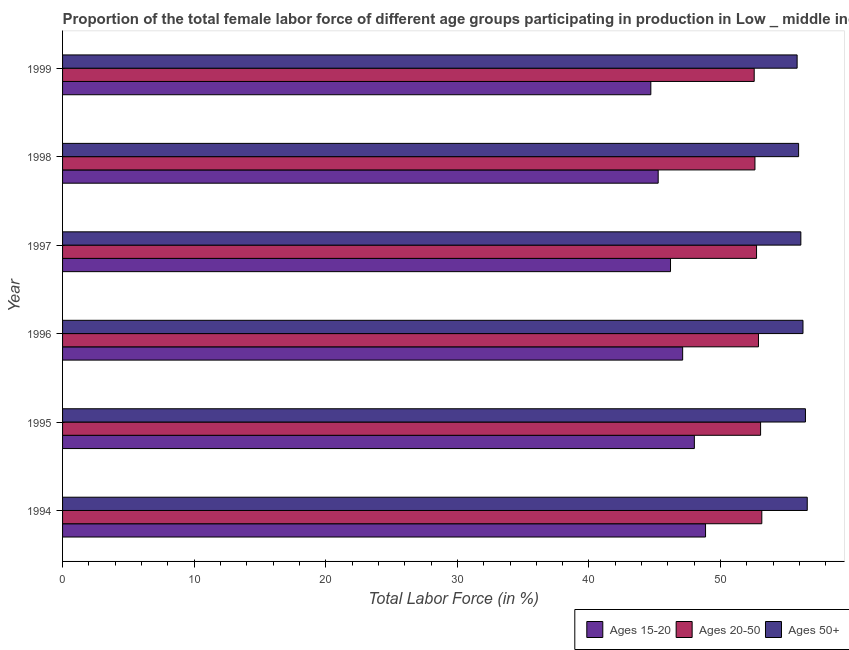How many different coloured bars are there?
Your answer should be compact. 3. Are the number of bars per tick equal to the number of legend labels?
Provide a short and direct response. Yes. Are the number of bars on each tick of the Y-axis equal?
Provide a short and direct response. Yes. How many bars are there on the 6th tick from the top?
Your response must be concise. 3. How many bars are there on the 2nd tick from the bottom?
Provide a succinct answer. 3. In how many cases, is the number of bars for a given year not equal to the number of legend labels?
Your response must be concise. 0. What is the percentage of female labor force within the age group 20-50 in 1999?
Give a very brief answer. 52.55. Across all years, what is the maximum percentage of female labor force within the age group 20-50?
Provide a succinct answer. 53.13. Across all years, what is the minimum percentage of female labor force within the age group 15-20?
Your answer should be compact. 44.7. In which year was the percentage of female labor force above age 50 minimum?
Offer a terse response. 1999. What is the total percentage of female labor force within the age group 20-50 in the graph?
Your answer should be compact. 316.95. What is the difference between the percentage of female labor force above age 50 in 1995 and that in 1996?
Keep it short and to the point. 0.19. What is the difference between the percentage of female labor force above age 50 in 1998 and the percentage of female labor force within the age group 20-50 in 1999?
Keep it short and to the point. 3.37. What is the average percentage of female labor force within the age group 15-20 per year?
Offer a very short reply. 46.69. In the year 1996, what is the difference between the percentage of female labor force above age 50 and percentage of female labor force within the age group 20-50?
Your answer should be very brief. 3.38. Is the percentage of female labor force within the age group 20-50 in 1994 less than that in 1998?
Ensure brevity in your answer.  No. What is the difference between the highest and the second highest percentage of female labor force within the age group 20-50?
Give a very brief answer. 0.09. What is the difference between the highest and the lowest percentage of female labor force within the age group 20-50?
Your response must be concise. 0.58. What does the 1st bar from the top in 1996 represents?
Your response must be concise. Ages 50+. What does the 3rd bar from the bottom in 1998 represents?
Your response must be concise. Ages 50+. How many bars are there?
Make the answer very short. 18. What is the difference between two consecutive major ticks on the X-axis?
Provide a short and direct response. 10. Are the values on the major ticks of X-axis written in scientific E-notation?
Your answer should be compact. No. Does the graph contain grids?
Your answer should be very brief. No. How many legend labels are there?
Your answer should be compact. 3. How are the legend labels stacked?
Make the answer very short. Horizontal. What is the title of the graph?
Give a very brief answer. Proportion of the total female labor force of different age groups participating in production in Low _ middle income. What is the label or title of the X-axis?
Provide a short and direct response. Total Labor Force (in %). What is the Total Labor Force (in %) in Ages 15-20 in 1994?
Make the answer very short. 48.86. What is the Total Labor Force (in %) in Ages 20-50 in 1994?
Provide a succinct answer. 53.13. What is the Total Labor Force (in %) of Ages 50+ in 1994?
Offer a very short reply. 56.59. What is the Total Labor Force (in %) in Ages 15-20 in 1995?
Give a very brief answer. 48.01. What is the Total Labor Force (in %) of Ages 20-50 in 1995?
Offer a very short reply. 53.04. What is the Total Labor Force (in %) in Ages 50+ in 1995?
Keep it short and to the point. 56.45. What is the Total Labor Force (in %) of Ages 15-20 in 1996?
Your response must be concise. 47.12. What is the Total Labor Force (in %) of Ages 20-50 in 1996?
Make the answer very short. 52.88. What is the Total Labor Force (in %) of Ages 50+ in 1996?
Ensure brevity in your answer.  56.26. What is the Total Labor Force (in %) of Ages 15-20 in 1997?
Offer a very short reply. 46.2. What is the Total Labor Force (in %) in Ages 20-50 in 1997?
Make the answer very short. 52.73. What is the Total Labor Force (in %) of Ages 50+ in 1997?
Provide a succinct answer. 56.1. What is the Total Labor Force (in %) in Ages 15-20 in 1998?
Your response must be concise. 45.26. What is the Total Labor Force (in %) in Ages 20-50 in 1998?
Make the answer very short. 52.61. What is the Total Labor Force (in %) of Ages 50+ in 1998?
Your response must be concise. 55.93. What is the Total Labor Force (in %) in Ages 15-20 in 1999?
Make the answer very short. 44.7. What is the Total Labor Force (in %) in Ages 20-50 in 1999?
Ensure brevity in your answer.  52.55. What is the Total Labor Force (in %) in Ages 50+ in 1999?
Keep it short and to the point. 55.82. Across all years, what is the maximum Total Labor Force (in %) of Ages 15-20?
Give a very brief answer. 48.86. Across all years, what is the maximum Total Labor Force (in %) of Ages 20-50?
Keep it short and to the point. 53.13. Across all years, what is the maximum Total Labor Force (in %) of Ages 50+?
Keep it short and to the point. 56.59. Across all years, what is the minimum Total Labor Force (in %) in Ages 15-20?
Offer a very short reply. 44.7. Across all years, what is the minimum Total Labor Force (in %) of Ages 20-50?
Offer a terse response. 52.55. Across all years, what is the minimum Total Labor Force (in %) in Ages 50+?
Offer a terse response. 55.82. What is the total Total Labor Force (in %) in Ages 15-20 in the graph?
Your response must be concise. 280.14. What is the total Total Labor Force (in %) of Ages 20-50 in the graph?
Offer a very short reply. 316.95. What is the total Total Labor Force (in %) of Ages 50+ in the graph?
Offer a terse response. 337.14. What is the difference between the Total Labor Force (in %) of Ages 15-20 in 1994 and that in 1995?
Give a very brief answer. 0.85. What is the difference between the Total Labor Force (in %) of Ages 20-50 in 1994 and that in 1995?
Offer a terse response. 0.09. What is the difference between the Total Labor Force (in %) of Ages 50+ in 1994 and that in 1995?
Provide a short and direct response. 0.14. What is the difference between the Total Labor Force (in %) of Ages 15-20 in 1994 and that in 1996?
Make the answer very short. 1.74. What is the difference between the Total Labor Force (in %) of Ages 20-50 in 1994 and that in 1996?
Ensure brevity in your answer.  0.25. What is the difference between the Total Labor Force (in %) in Ages 50+ in 1994 and that in 1996?
Keep it short and to the point. 0.33. What is the difference between the Total Labor Force (in %) of Ages 15-20 in 1994 and that in 1997?
Offer a terse response. 2.66. What is the difference between the Total Labor Force (in %) of Ages 20-50 in 1994 and that in 1997?
Your answer should be very brief. 0.4. What is the difference between the Total Labor Force (in %) of Ages 50+ in 1994 and that in 1997?
Provide a short and direct response. 0.49. What is the difference between the Total Labor Force (in %) of Ages 15-20 in 1994 and that in 1998?
Give a very brief answer. 3.6. What is the difference between the Total Labor Force (in %) in Ages 20-50 in 1994 and that in 1998?
Your answer should be compact. 0.52. What is the difference between the Total Labor Force (in %) of Ages 50+ in 1994 and that in 1998?
Your response must be concise. 0.66. What is the difference between the Total Labor Force (in %) in Ages 15-20 in 1994 and that in 1999?
Offer a very short reply. 4.16. What is the difference between the Total Labor Force (in %) of Ages 20-50 in 1994 and that in 1999?
Keep it short and to the point. 0.58. What is the difference between the Total Labor Force (in %) of Ages 50+ in 1994 and that in 1999?
Your response must be concise. 0.77. What is the difference between the Total Labor Force (in %) in Ages 15-20 in 1995 and that in 1996?
Ensure brevity in your answer.  0.89. What is the difference between the Total Labor Force (in %) in Ages 20-50 in 1995 and that in 1996?
Your answer should be compact. 0.16. What is the difference between the Total Labor Force (in %) of Ages 50+ in 1995 and that in 1996?
Ensure brevity in your answer.  0.19. What is the difference between the Total Labor Force (in %) in Ages 15-20 in 1995 and that in 1997?
Give a very brief answer. 1.81. What is the difference between the Total Labor Force (in %) in Ages 20-50 in 1995 and that in 1997?
Provide a short and direct response. 0.31. What is the difference between the Total Labor Force (in %) of Ages 15-20 in 1995 and that in 1998?
Provide a succinct answer. 2.75. What is the difference between the Total Labor Force (in %) of Ages 20-50 in 1995 and that in 1998?
Provide a succinct answer. 0.43. What is the difference between the Total Labor Force (in %) in Ages 50+ in 1995 and that in 1998?
Ensure brevity in your answer.  0.52. What is the difference between the Total Labor Force (in %) in Ages 15-20 in 1995 and that in 1999?
Provide a succinct answer. 3.31. What is the difference between the Total Labor Force (in %) in Ages 20-50 in 1995 and that in 1999?
Provide a short and direct response. 0.49. What is the difference between the Total Labor Force (in %) of Ages 50+ in 1995 and that in 1999?
Your answer should be compact. 0.63. What is the difference between the Total Labor Force (in %) of Ages 15-20 in 1996 and that in 1997?
Your response must be concise. 0.92. What is the difference between the Total Labor Force (in %) of Ages 20-50 in 1996 and that in 1997?
Provide a short and direct response. 0.15. What is the difference between the Total Labor Force (in %) of Ages 50+ in 1996 and that in 1997?
Keep it short and to the point. 0.16. What is the difference between the Total Labor Force (in %) in Ages 15-20 in 1996 and that in 1998?
Provide a short and direct response. 1.86. What is the difference between the Total Labor Force (in %) of Ages 20-50 in 1996 and that in 1998?
Give a very brief answer. 0.27. What is the difference between the Total Labor Force (in %) in Ages 50+ in 1996 and that in 1998?
Provide a succinct answer. 0.33. What is the difference between the Total Labor Force (in %) of Ages 15-20 in 1996 and that in 1999?
Your answer should be compact. 2.42. What is the difference between the Total Labor Force (in %) in Ages 20-50 in 1996 and that in 1999?
Your answer should be very brief. 0.32. What is the difference between the Total Labor Force (in %) of Ages 50+ in 1996 and that in 1999?
Your response must be concise. 0.44. What is the difference between the Total Labor Force (in %) of Ages 15-20 in 1997 and that in 1998?
Your answer should be compact. 0.94. What is the difference between the Total Labor Force (in %) in Ages 20-50 in 1997 and that in 1998?
Your answer should be compact. 0.12. What is the difference between the Total Labor Force (in %) in Ages 50+ in 1997 and that in 1998?
Provide a succinct answer. 0.17. What is the difference between the Total Labor Force (in %) in Ages 15-20 in 1997 and that in 1999?
Make the answer very short. 1.5. What is the difference between the Total Labor Force (in %) in Ages 20-50 in 1997 and that in 1999?
Your answer should be very brief. 0.18. What is the difference between the Total Labor Force (in %) of Ages 50+ in 1997 and that in 1999?
Make the answer very short. 0.28. What is the difference between the Total Labor Force (in %) of Ages 15-20 in 1998 and that in 1999?
Ensure brevity in your answer.  0.56. What is the difference between the Total Labor Force (in %) of Ages 20-50 in 1998 and that in 1999?
Your response must be concise. 0.06. What is the difference between the Total Labor Force (in %) of Ages 50+ in 1998 and that in 1999?
Offer a very short reply. 0.11. What is the difference between the Total Labor Force (in %) in Ages 15-20 in 1994 and the Total Labor Force (in %) in Ages 20-50 in 1995?
Your answer should be very brief. -4.18. What is the difference between the Total Labor Force (in %) in Ages 15-20 in 1994 and the Total Labor Force (in %) in Ages 50+ in 1995?
Your response must be concise. -7.59. What is the difference between the Total Labor Force (in %) of Ages 20-50 in 1994 and the Total Labor Force (in %) of Ages 50+ in 1995?
Offer a terse response. -3.32. What is the difference between the Total Labor Force (in %) of Ages 15-20 in 1994 and the Total Labor Force (in %) of Ages 20-50 in 1996?
Give a very brief answer. -4.02. What is the difference between the Total Labor Force (in %) in Ages 15-20 in 1994 and the Total Labor Force (in %) in Ages 50+ in 1996?
Your response must be concise. -7.4. What is the difference between the Total Labor Force (in %) in Ages 20-50 in 1994 and the Total Labor Force (in %) in Ages 50+ in 1996?
Your answer should be compact. -3.13. What is the difference between the Total Labor Force (in %) of Ages 15-20 in 1994 and the Total Labor Force (in %) of Ages 20-50 in 1997?
Offer a terse response. -3.88. What is the difference between the Total Labor Force (in %) in Ages 15-20 in 1994 and the Total Labor Force (in %) in Ages 50+ in 1997?
Your answer should be very brief. -7.24. What is the difference between the Total Labor Force (in %) of Ages 20-50 in 1994 and the Total Labor Force (in %) of Ages 50+ in 1997?
Make the answer very short. -2.97. What is the difference between the Total Labor Force (in %) in Ages 15-20 in 1994 and the Total Labor Force (in %) in Ages 20-50 in 1998?
Make the answer very short. -3.75. What is the difference between the Total Labor Force (in %) in Ages 15-20 in 1994 and the Total Labor Force (in %) in Ages 50+ in 1998?
Your answer should be very brief. -7.07. What is the difference between the Total Labor Force (in %) in Ages 20-50 in 1994 and the Total Labor Force (in %) in Ages 50+ in 1998?
Offer a very short reply. -2.8. What is the difference between the Total Labor Force (in %) of Ages 15-20 in 1994 and the Total Labor Force (in %) of Ages 20-50 in 1999?
Provide a succinct answer. -3.7. What is the difference between the Total Labor Force (in %) in Ages 15-20 in 1994 and the Total Labor Force (in %) in Ages 50+ in 1999?
Your response must be concise. -6.96. What is the difference between the Total Labor Force (in %) of Ages 20-50 in 1994 and the Total Labor Force (in %) of Ages 50+ in 1999?
Offer a terse response. -2.68. What is the difference between the Total Labor Force (in %) in Ages 15-20 in 1995 and the Total Labor Force (in %) in Ages 20-50 in 1996?
Your answer should be compact. -4.87. What is the difference between the Total Labor Force (in %) in Ages 15-20 in 1995 and the Total Labor Force (in %) in Ages 50+ in 1996?
Your answer should be compact. -8.25. What is the difference between the Total Labor Force (in %) of Ages 20-50 in 1995 and the Total Labor Force (in %) of Ages 50+ in 1996?
Offer a terse response. -3.22. What is the difference between the Total Labor Force (in %) of Ages 15-20 in 1995 and the Total Labor Force (in %) of Ages 20-50 in 1997?
Offer a terse response. -4.73. What is the difference between the Total Labor Force (in %) in Ages 15-20 in 1995 and the Total Labor Force (in %) in Ages 50+ in 1997?
Give a very brief answer. -8.09. What is the difference between the Total Labor Force (in %) of Ages 20-50 in 1995 and the Total Labor Force (in %) of Ages 50+ in 1997?
Give a very brief answer. -3.06. What is the difference between the Total Labor Force (in %) of Ages 15-20 in 1995 and the Total Labor Force (in %) of Ages 20-50 in 1998?
Keep it short and to the point. -4.6. What is the difference between the Total Labor Force (in %) in Ages 15-20 in 1995 and the Total Labor Force (in %) in Ages 50+ in 1998?
Make the answer very short. -7.92. What is the difference between the Total Labor Force (in %) in Ages 20-50 in 1995 and the Total Labor Force (in %) in Ages 50+ in 1998?
Make the answer very short. -2.89. What is the difference between the Total Labor Force (in %) in Ages 15-20 in 1995 and the Total Labor Force (in %) in Ages 20-50 in 1999?
Your answer should be compact. -4.55. What is the difference between the Total Labor Force (in %) in Ages 15-20 in 1995 and the Total Labor Force (in %) in Ages 50+ in 1999?
Your answer should be compact. -7.81. What is the difference between the Total Labor Force (in %) of Ages 20-50 in 1995 and the Total Labor Force (in %) of Ages 50+ in 1999?
Your answer should be compact. -2.78. What is the difference between the Total Labor Force (in %) of Ages 15-20 in 1996 and the Total Labor Force (in %) of Ages 20-50 in 1997?
Provide a short and direct response. -5.61. What is the difference between the Total Labor Force (in %) of Ages 15-20 in 1996 and the Total Labor Force (in %) of Ages 50+ in 1997?
Your answer should be compact. -8.98. What is the difference between the Total Labor Force (in %) in Ages 20-50 in 1996 and the Total Labor Force (in %) in Ages 50+ in 1997?
Keep it short and to the point. -3.22. What is the difference between the Total Labor Force (in %) of Ages 15-20 in 1996 and the Total Labor Force (in %) of Ages 20-50 in 1998?
Keep it short and to the point. -5.49. What is the difference between the Total Labor Force (in %) of Ages 15-20 in 1996 and the Total Labor Force (in %) of Ages 50+ in 1998?
Ensure brevity in your answer.  -8.81. What is the difference between the Total Labor Force (in %) in Ages 20-50 in 1996 and the Total Labor Force (in %) in Ages 50+ in 1998?
Your answer should be very brief. -3.05. What is the difference between the Total Labor Force (in %) of Ages 15-20 in 1996 and the Total Labor Force (in %) of Ages 20-50 in 1999?
Ensure brevity in your answer.  -5.44. What is the difference between the Total Labor Force (in %) in Ages 15-20 in 1996 and the Total Labor Force (in %) in Ages 50+ in 1999?
Offer a very short reply. -8.7. What is the difference between the Total Labor Force (in %) in Ages 20-50 in 1996 and the Total Labor Force (in %) in Ages 50+ in 1999?
Your answer should be compact. -2.94. What is the difference between the Total Labor Force (in %) in Ages 15-20 in 1997 and the Total Labor Force (in %) in Ages 20-50 in 1998?
Keep it short and to the point. -6.42. What is the difference between the Total Labor Force (in %) of Ages 15-20 in 1997 and the Total Labor Force (in %) of Ages 50+ in 1998?
Offer a very short reply. -9.73. What is the difference between the Total Labor Force (in %) of Ages 20-50 in 1997 and the Total Labor Force (in %) of Ages 50+ in 1998?
Your answer should be compact. -3.2. What is the difference between the Total Labor Force (in %) of Ages 15-20 in 1997 and the Total Labor Force (in %) of Ages 20-50 in 1999?
Ensure brevity in your answer.  -6.36. What is the difference between the Total Labor Force (in %) of Ages 15-20 in 1997 and the Total Labor Force (in %) of Ages 50+ in 1999?
Offer a terse response. -9.62. What is the difference between the Total Labor Force (in %) in Ages 20-50 in 1997 and the Total Labor Force (in %) in Ages 50+ in 1999?
Provide a short and direct response. -3.08. What is the difference between the Total Labor Force (in %) in Ages 15-20 in 1998 and the Total Labor Force (in %) in Ages 20-50 in 1999?
Your response must be concise. -7.3. What is the difference between the Total Labor Force (in %) of Ages 15-20 in 1998 and the Total Labor Force (in %) of Ages 50+ in 1999?
Offer a terse response. -10.56. What is the difference between the Total Labor Force (in %) of Ages 20-50 in 1998 and the Total Labor Force (in %) of Ages 50+ in 1999?
Offer a very short reply. -3.21. What is the average Total Labor Force (in %) of Ages 15-20 per year?
Provide a succinct answer. 46.69. What is the average Total Labor Force (in %) of Ages 20-50 per year?
Ensure brevity in your answer.  52.83. What is the average Total Labor Force (in %) in Ages 50+ per year?
Keep it short and to the point. 56.19. In the year 1994, what is the difference between the Total Labor Force (in %) in Ages 15-20 and Total Labor Force (in %) in Ages 20-50?
Offer a very short reply. -4.28. In the year 1994, what is the difference between the Total Labor Force (in %) of Ages 15-20 and Total Labor Force (in %) of Ages 50+?
Give a very brief answer. -7.73. In the year 1994, what is the difference between the Total Labor Force (in %) in Ages 20-50 and Total Labor Force (in %) in Ages 50+?
Make the answer very short. -3.45. In the year 1995, what is the difference between the Total Labor Force (in %) in Ages 15-20 and Total Labor Force (in %) in Ages 20-50?
Your answer should be very brief. -5.03. In the year 1995, what is the difference between the Total Labor Force (in %) of Ages 15-20 and Total Labor Force (in %) of Ages 50+?
Your answer should be compact. -8.44. In the year 1995, what is the difference between the Total Labor Force (in %) of Ages 20-50 and Total Labor Force (in %) of Ages 50+?
Provide a succinct answer. -3.41. In the year 1996, what is the difference between the Total Labor Force (in %) in Ages 15-20 and Total Labor Force (in %) in Ages 20-50?
Ensure brevity in your answer.  -5.76. In the year 1996, what is the difference between the Total Labor Force (in %) of Ages 15-20 and Total Labor Force (in %) of Ages 50+?
Give a very brief answer. -9.14. In the year 1996, what is the difference between the Total Labor Force (in %) in Ages 20-50 and Total Labor Force (in %) in Ages 50+?
Your response must be concise. -3.38. In the year 1997, what is the difference between the Total Labor Force (in %) of Ages 15-20 and Total Labor Force (in %) of Ages 20-50?
Ensure brevity in your answer.  -6.54. In the year 1997, what is the difference between the Total Labor Force (in %) in Ages 15-20 and Total Labor Force (in %) in Ages 50+?
Offer a terse response. -9.9. In the year 1997, what is the difference between the Total Labor Force (in %) of Ages 20-50 and Total Labor Force (in %) of Ages 50+?
Your answer should be compact. -3.37. In the year 1998, what is the difference between the Total Labor Force (in %) in Ages 15-20 and Total Labor Force (in %) in Ages 20-50?
Offer a very short reply. -7.35. In the year 1998, what is the difference between the Total Labor Force (in %) of Ages 15-20 and Total Labor Force (in %) of Ages 50+?
Make the answer very short. -10.67. In the year 1998, what is the difference between the Total Labor Force (in %) of Ages 20-50 and Total Labor Force (in %) of Ages 50+?
Offer a terse response. -3.32. In the year 1999, what is the difference between the Total Labor Force (in %) of Ages 15-20 and Total Labor Force (in %) of Ages 20-50?
Ensure brevity in your answer.  -7.85. In the year 1999, what is the difference between the Total Labor Force (in %) of Ages 15-20 and Total Labor Force (in %) of Ages 50+?
Provide a succinct answer. -11.12. In the year 1999, what is the difference between the Total Labor Force (in %) of Ages 20-50 and Total Labor Force (in %) of Ages 50+?
Provide a short and direct response. -3.26. What is the ratio of the Total Labor Force (in %) of Ages 15-20 in 1994 to that in 1995?
Offer a terse response. 1.02. What is the ratio of the Total Labor Force (in %) of Ages 20-50 in 1994 to that in 1995?
Give a very brief answer. 1. What is the ratio of the Total Labor Force (in %) in Ages 15-20 in 1994 to that in 1996?
Offer a very short reply. 1.04. What is the ratio of the Total Labor Force (in %) in Ages 15-20 in 1994 to that in 1997?
Your answer should be compact. 1.06. What is the ratio of the Total Labor Force (in %) in Ages 20-50 in 1994 to that in 1997?
Keep it short and to the point. 1.01. What is the ratio of the Total Labor Force (in %) of Ages 50+ in 1994 to that in 1997?
Provide a succinct answer. 1.01. What is the ratio of the Total Labor Force (in %) in Ages 15-20 in 1994 to that in 1998?
Ensure brevity in your answer.  1.08. What is the ratio of the Total Labor Force (in %) in Ages 20-50 in 1994 to that in 1998?
Provide a short and direct response. 1.01. What is the ratio of the Total Labor Force (in %) of Ages 50+ in 1994 to that in 1998?
Your response must be concise. 1.01. What is the ratio of the Total Labor Force (in %) of Ages 15-20 in 1994 to that in 1999?
Provide a short and direct response. 1.09. What is the ratio of the Total Labor Force (in %) of Ages 20-50 in 1994 to that in 1999?
Provide a succinct answer. 1.01. What is the ratio of the Total Labor Force (in %) of Ages 50+ in 1994 to that in 1999?
Keep it short and to the point. 1.01. What is the ratio of the Total Labor Force (in %) in Ages 15-20 in 1995 to that in 1996?
Your answer should be very brief. 1.02. What is the ratio of the Total Labor Force (in %) in Ages 15-20 in 1995 to that in 1997?
Provide a short and direct response. 1.04. What is the ratio of the Total Labor Force (in %) of Ages 50+ in 1995 to that in 1997?
Offer a terse response. 1.01. What is the ratio of the Total Labor Force (in %) of Ages 15-20 in 1995 to that in 1998?
Your answer should be compact. 1.06. What is the ratio of the Total Labor Force (in %) in Ages 20-50 in 1995 to that in 1998?
Provide a succinct answer. 1.01. What is the ratio of the Total Labor Force (in %) of Ages 50+ in 1995 to that in 1998?
Provide a succinct answer. 1.01. What is the ratio of the Total Labor Force (in %) of Ages 15-20 in 1995 to that in 1999?
Provide a short and direct response. 1.07. What is the ratio of the Total Labor Force (in %) of Ages 20-50 in 1995 to that in 1999?
Keep it short and to the point. 1.01. What is the ratio of the Total Labor Force (in %) of Ages 50+ in 1995 to that in 1999?
Your answer should be very brief. 1.01. What is the ratio of the Total Labor Force (in %) of Ages 15-20 in 1996 to that in 1997?
Your answer should be compact. 1.02. What is the ratio of the Total Labor Force (in %) of Ages 15-20 in 1996 to that in 1998?
Your response must be concise. 1.04. What is the ratio of the Total Labor Force (in %) of Ages 20-50 in 1996 to that in 1998?
Give a very brief answer. 1.01. What is the ratio of the Total Labor Force (in %) of Ages 50+ in 1996 to that in 1998?
Keep it short and to the point. 1.01. What is the ratio of the Total Labor Force (in %) of Ages 15-20 in 1996 to that in 1999?
Offer a terse response. 1.05. What is the ratio of the Total Labor Force (in %) in Ages 20-50 in 1996 to that in 1999?
Ensure brevity in your answer.  1.01. What is the ratio of the Total Labor Force (in %) of Ages 15-20 in 1997 to that in 1998?
Provide a short and direct response. 1.02. What is the ratio of the Total Labor Force (in %) of Ages 20-50 in 1997 to that in 1998?
Keep it short and to the point. 1. What is the ratio of the Total Labor Force (in %) of Ages 15-20 in 1997 to that in 1999?
Give a very brief answer. 1.03. What is the ratio of the Total Labor Force (in %) in Ages 50+ in 1997 to that in 1999?
Provide a succinct answer. 1.01. What is the ratio of the Total Labor Force (in %) in Ages 15-20 in 1998 to that in 1999?
Provide a succinct answer. 1.01. What is the ratio of the Total Labor Force (in %) of Ages 20-50 in 1998 to that in 1999?
Keep it short and to the point. 1. What is the ratio of the Total Labor Force (in %) in Ages 50+ in 1998 to that in 1999?
Give a very brief answer. 1. What is the difference between the highest and the second highest Total Labor Force (in %) of Ages 15-20?
Provide a short and direct response. 0.85. What is the difference between the highest and the second highest Total Labor Force (in %) of Ages 20-50?
Make the answer very short. 0.09. What is the difference between the highest and the second highest Total Labor Force (in %) of Ages 50+?
Your response must be concise. 0.14. What is the difference between the highest and the lowest Total Labor Force (in %) in Ages 15-20?
Your answer should be compact. 4.16. What is the difference between the highest and the lowest Total Labor Force (in %) in Ages 20-50?
Ensure brevity in your answer.  0.58. What is the difference between the highest and the lowest Total Labor Force (in %) of Ages 50+?
Your response must be concise. 0.77. 